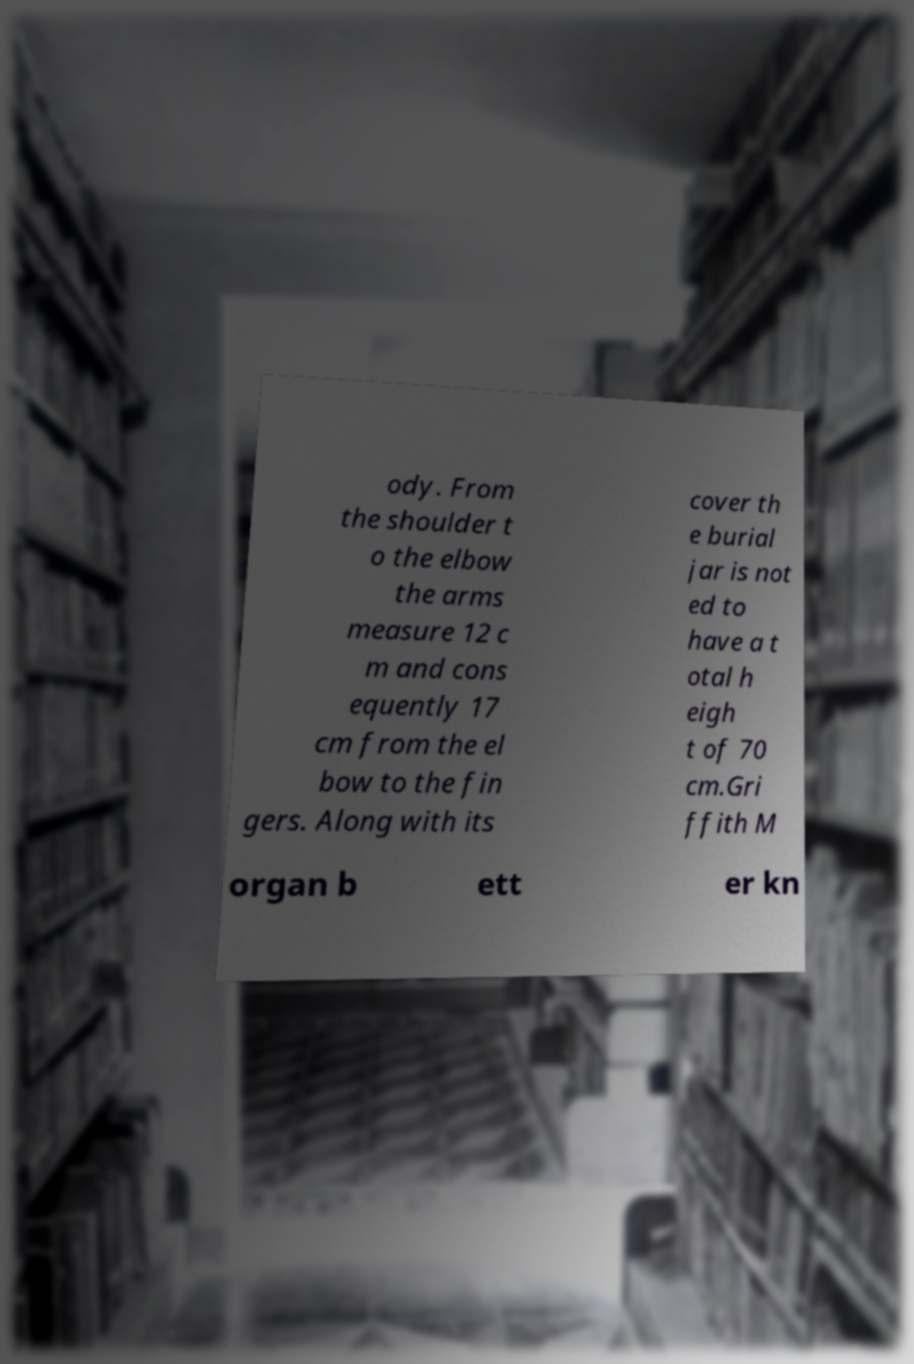I need the written content from this picture converted into text. Can you do that? ody. From the shoulder t o the elbow the arms measure 12 c m and cons equently 17 cm from the el bow to the fin gers. Along with its cover th e burial jar is not ed to have a t otal h eigh t of 70 cm.Gri ffith M organ b ett er kn 